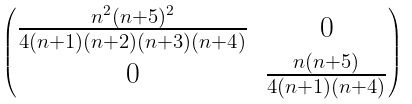<formula> <loc_0><loc_0><loc_500><loc_500>\begin{pmatrix} \frac { n ^ { 2 } ( n + 5 ) ^ { 2 } } { 4 ( n + 1 ) ( n + 2 ) ( n + 3 ) ( n + 4 ) } & 0 \\ 0 & \frac { n ( n + 5 ) } { 4 ( n + 1 ) ( n + 4 ) } \end{pmatrix}</formula> 